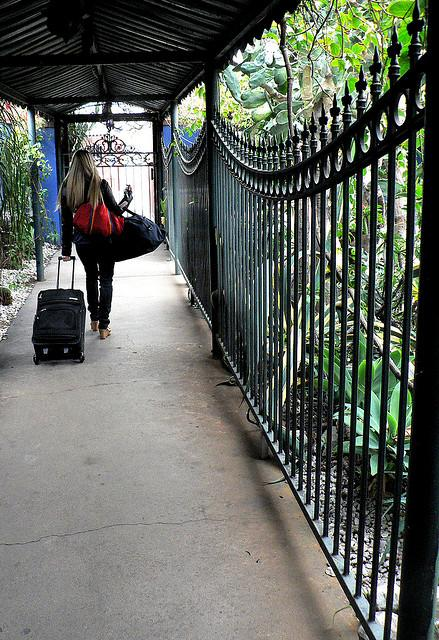Where is the woman likely heading?

Choices:
A) vacation
B) work
C) dinner
D) school vacation 